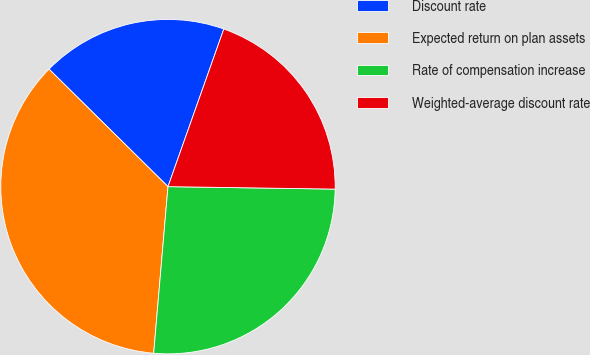Convert chart to OTSL. <chart><loc_0><loc_0><loc_500><loc_500><pie_chart><fcel>Discount rate<fcel>Expected return on plan assets<fcel>Rate of compensation increase<fcel>Weighted-average discount rate<nl><fcel>18.02%<fcel>36.04%<fcel>26.13%<fcel>19.82%<nl></chart> 